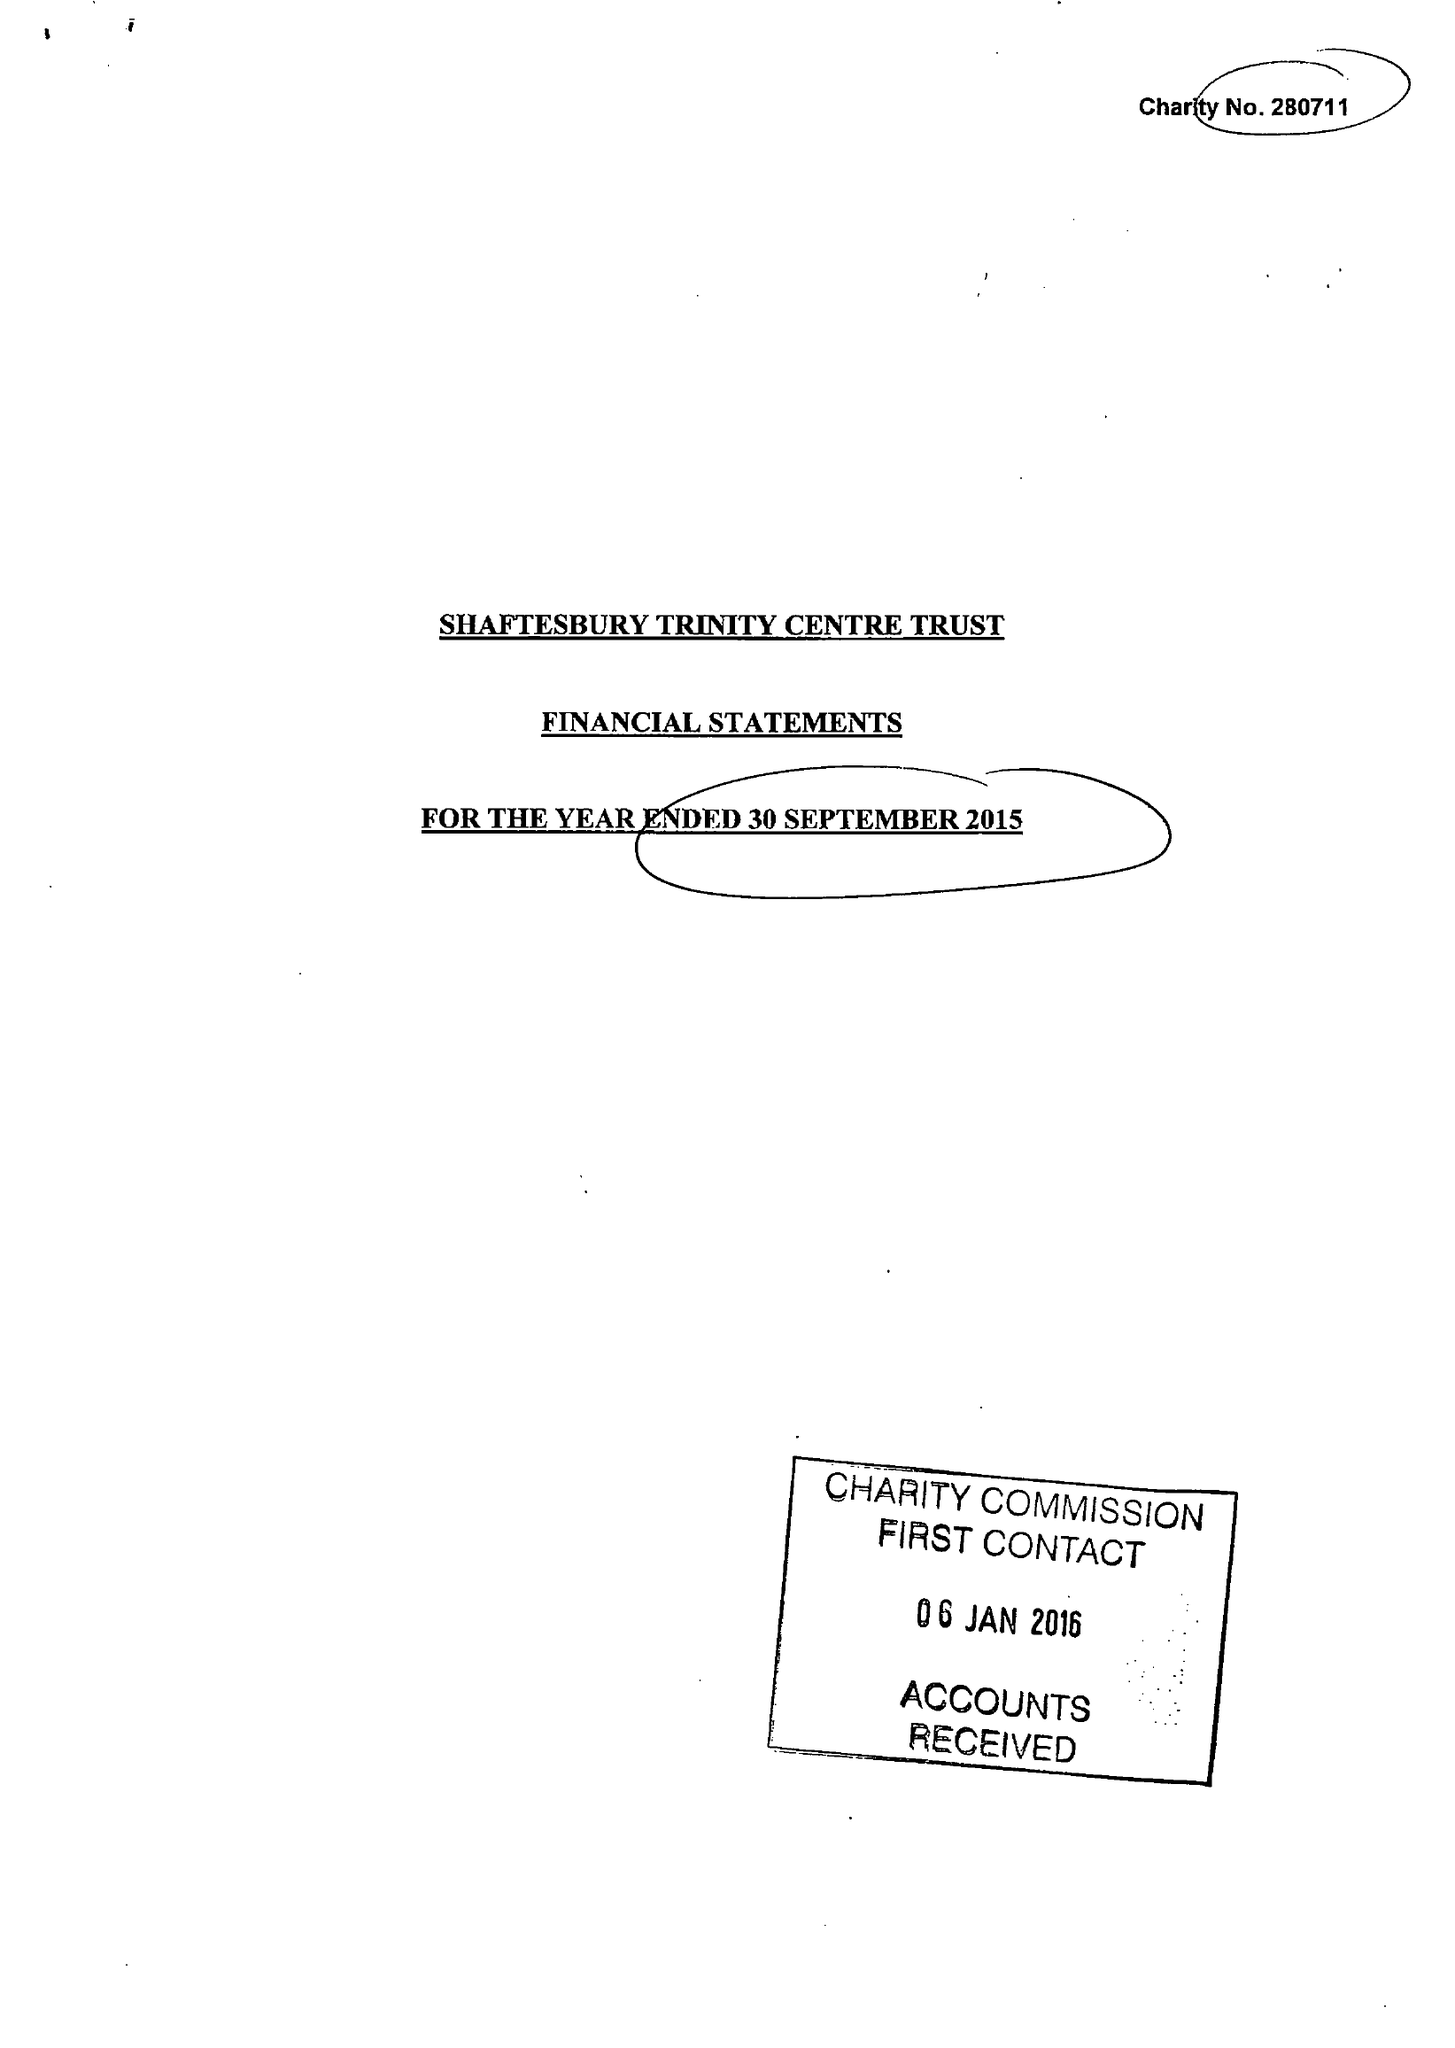What is the value for the spending_annually_in_british_pounds?
Answer the question using a single word or phrase. 38136.00 